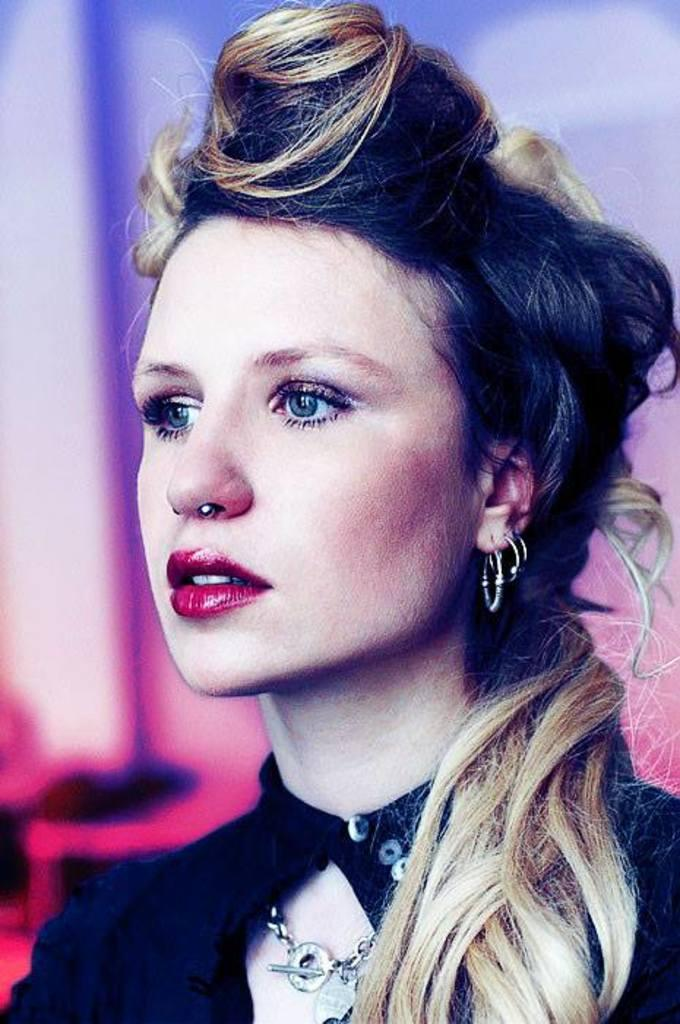What is the main subject of the image? The main subject of the image is a woman. What type of accessory is the woman wearing? The woman is wearing earrings. What color clothes is the woman wearing? The woman is wearing black color clothes. Is the woman in the image protesting in quicksand? There is no indication of quicksand or a protest in the image; it simply features a woman wearing earrings and black clothes. 